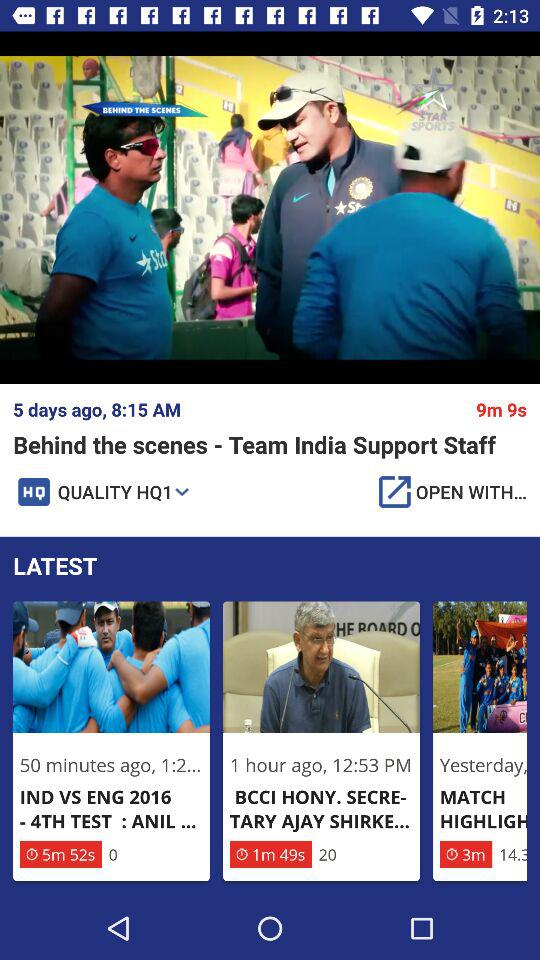What's the time of the posted video "Behind the scenes - Team India Support Staff"? The time is 8:15 AM. 